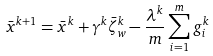<formula> <loc_0><loc_0><loc_500><loc_500>\bar { x } ^ { k + 1 } = \bar { x } ^ { k } + \gamma ^ { k } \bar { \zeta } _ { w } ^ { k } - \frac { \lambda ^ { k } } { m } \sum _ { i = 1 } ^ { m } g _ { i } ^ { k }</formula> 